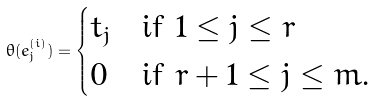Convert formula to latex. <formula><loc_0><loc_0><loc_500><loc_500>\theta ( e ^ { ( i ) } _ { j } ) = \begin{cases} t _ { j } & \text {if $1 \leq j \leq r$} \\ 0 & \text {if $r+1 \leq j \leq m$.} \end{cases}</formula> 